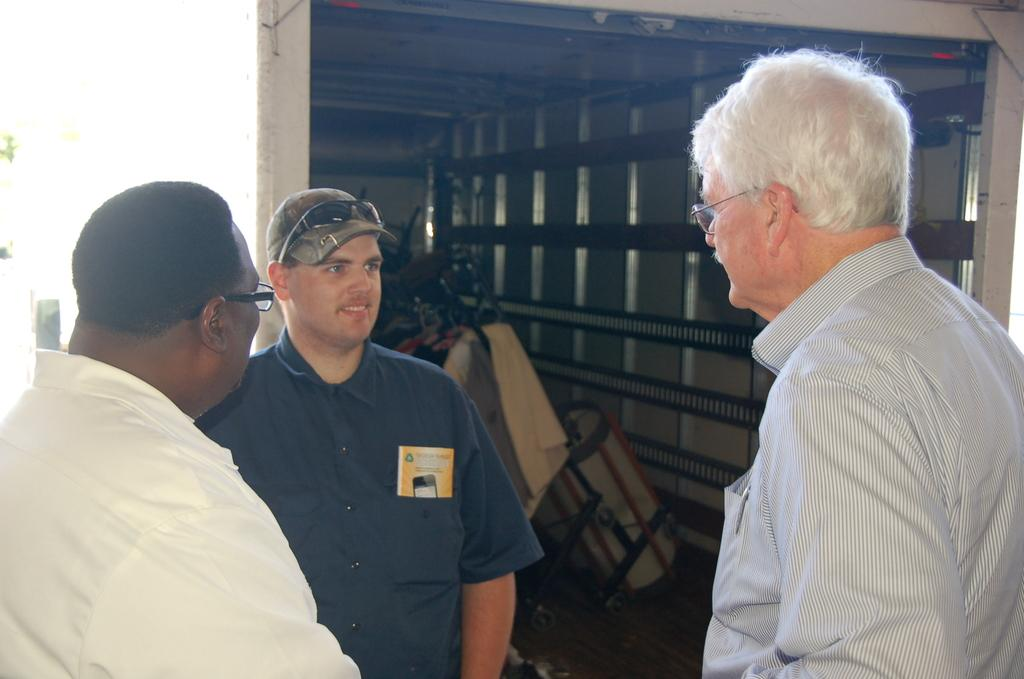How many people are present in the image? There are three men standing in the image. What vehicle can be seen in the image? There is a truck in the image. What is happening with the truck in the image? Objects are placed inside the truck. What type of wilderness can be heard in the background of the image? There is no sound or wilderness present in the image, as it is a still photograph. 